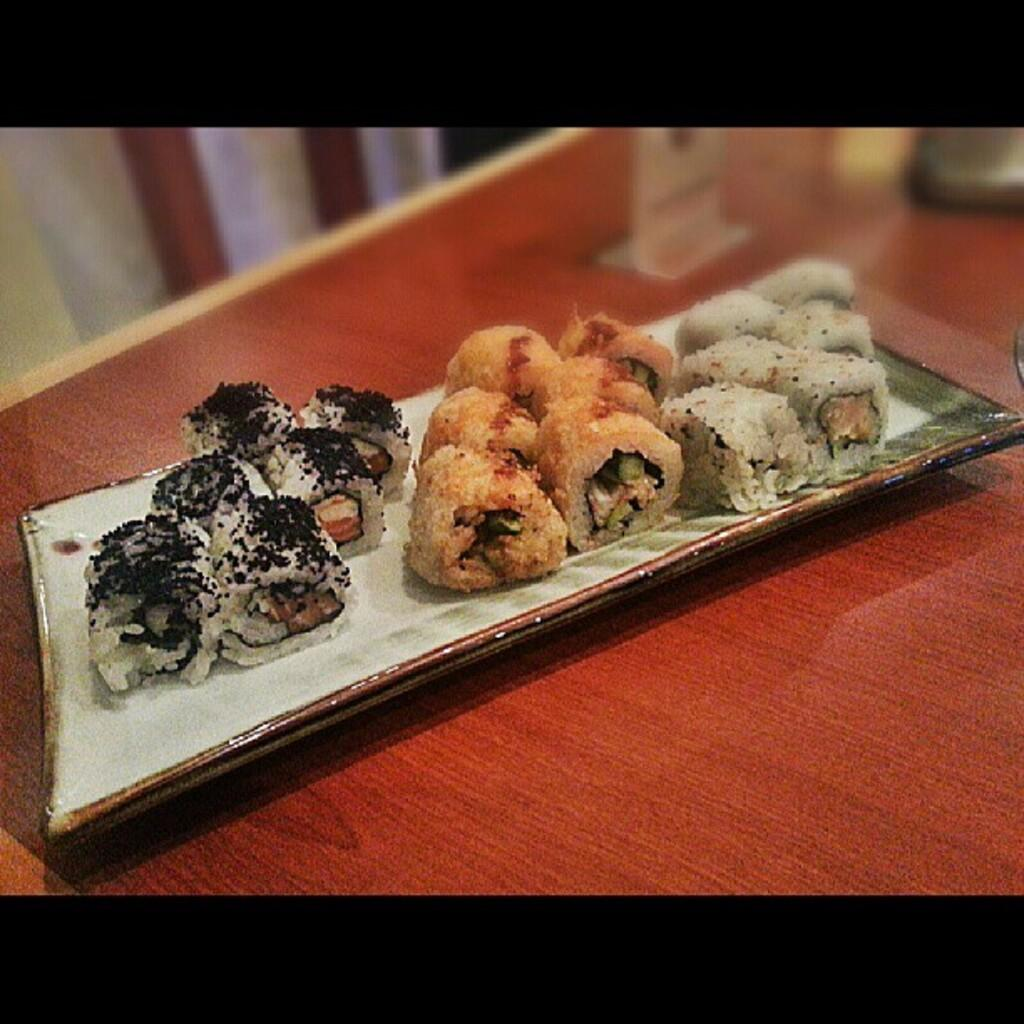What is on the plate that is visible in the image? There is food on a plate in the image. What type of surface is the food and other objects placed on? The objects are on a wooden surface in the image. Can you describe the objects visible in the top left of the image? Unfortunately, the provided facts do not specify the objects visible in the top left of the image. What type of glass can be seen in the field in the image? There is no glass or field present in the image. 